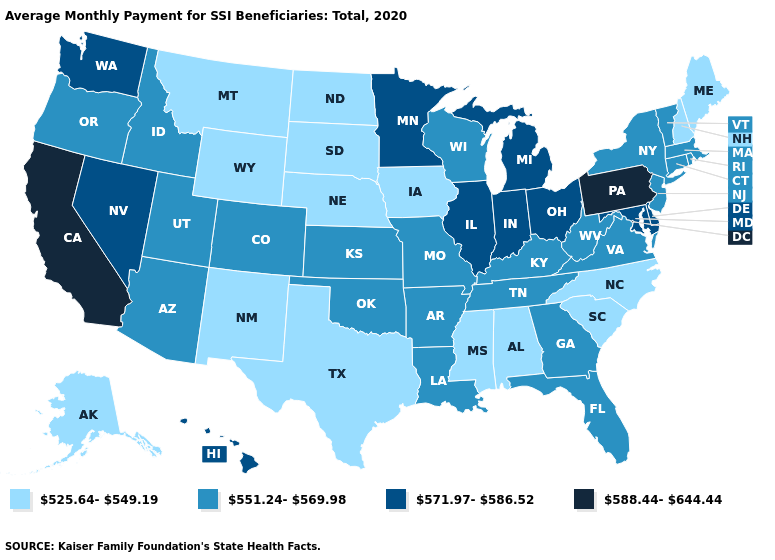Does the first symbol in the legend represent the smallest category?
Give a very brief answer. Yes. What is the value of West Virginia?
Concise answer only. 551.24-569.98. What is the value of Kansas?
Quick response, please. 551.24-569.98. Does Ohio have the lowest value in the MidWest?
Short answer required. No. What is the value of Arizona?
Short answer required. 551.24-569.98. Does Louisiana have the highest value in the South?
Concise answer only. No. Name the states that have a value in the range 571.97-586.52?
Quick response, please. Delaware, Hawaii, Illinois, Indiana, Maryland, Michigan, Minnesota, Nevada, Ohio, Washington. What is the value of Oregon?
Concise answer only. 551.24-569.98. Is the legend a continuous bar?
Short answer required. No. What is the value of California?
Keep it brief. 588.44-644.44. Does California have the highest value in the USA?
Short answer required. Yes. How many symbols are there in the legend?
Be succinct. 4. Name the states that have a value in the range 588.44-644.44?
Keep it brief. California, Pennsylvania. Does South Dakota have the lowest value in the USA?
Give a very brief answer. Yes. Name the states that have a value in the range 525.64-549.19?
Quick response, please. Alabama, Alaska, Iowa, Maine, Mississippi, Montana, Nebraska, New Hampshire, New Mexico, North Carolina, North Dakota, South Carolina, South Dakota, Texas, Wyoming. 